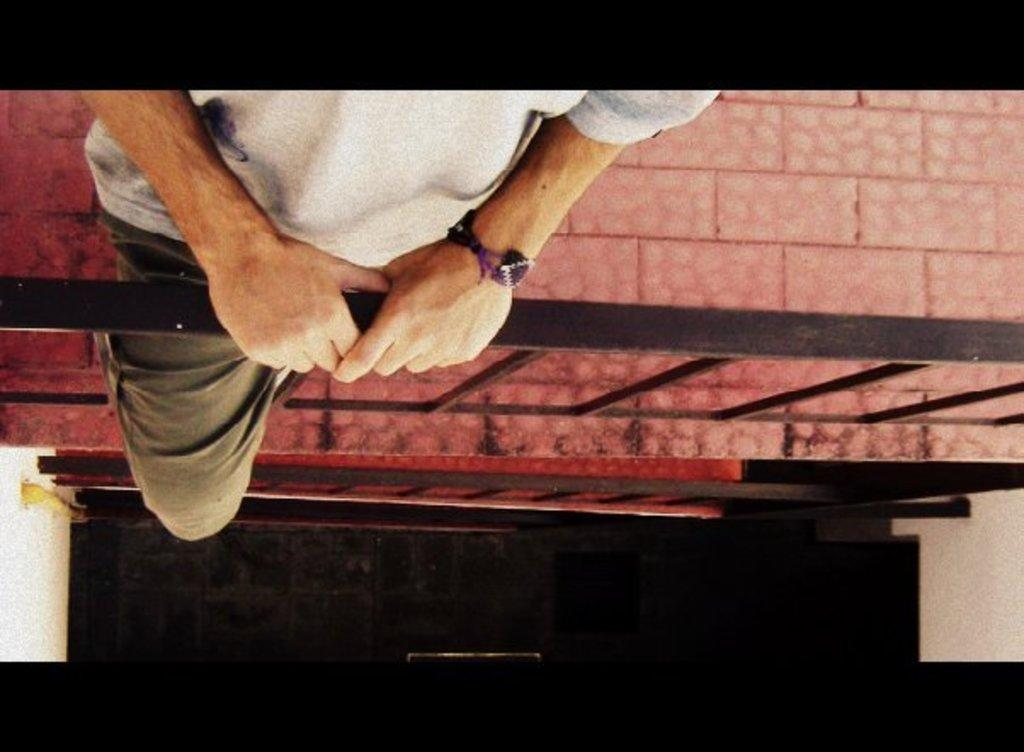What is the main subject of the image? There is a man standing in the image. Where is the man standing? The man is standing on the floor. What can be seen near the man in the image? There is a railing made of metal in the image, and it is in front of the man. What is at the bottom of the image? There is a wall at the bottom of the image. What type of furniture is being polished in the image? There is no furniture present in the image, nor is there any indication of polishing. 